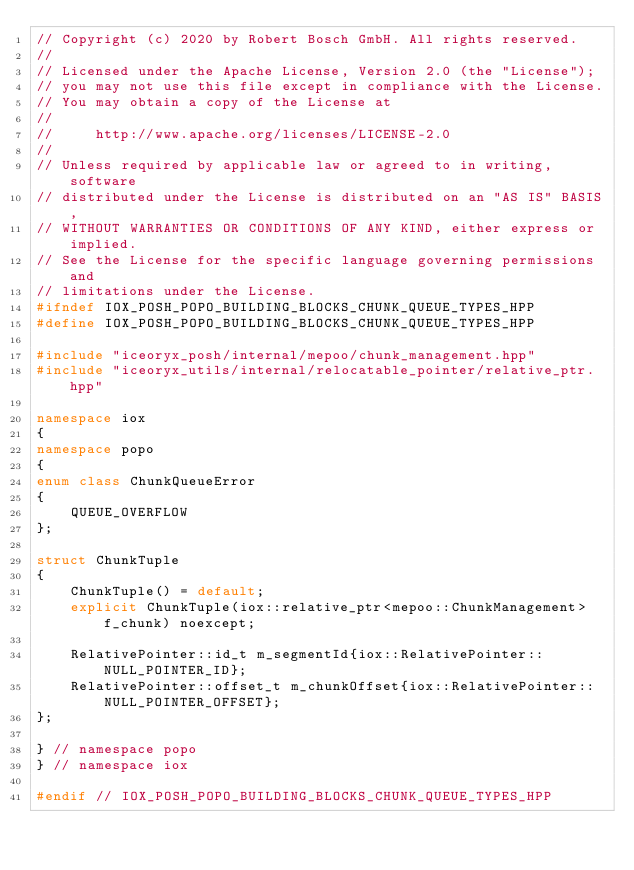Convert code to text. <code><loc_0><loc_0><loc_500><loc_500><_C++_>// Copyright (c) 2020 by Robert Bosch GmbH. All rights reserved.
//
// Licensed under the Apache License, Version 2.0 (the "License");
// you may not use this file except in compliance with the License.
// You may obtain a copy of the License at
//
//     http://www.apache.org/licenses/LICENSE-2.0
//
// Unless required by applicable law or agreed to in writing, software
// distributed under the License is distributed on an "AS IS" BASIS,
// WITHOUT WARRANTIES OR CONDITIONS OF ANY KIND, either express or implied.
// See the License for the specific language governing permissions and
// limitations under the License.
#ifndef IOX_POSH_POPO_BUILDING_BLOCKS_CHUNK_QUEUE_TYPES_HPP
#define IOX_POSH_POPO_BUILDING_BLOCKS_CHUNK_QUEUE_TYPES_HPP

#include "iceoryx_posh/internal/mepoo/chunk_management.hpp"
#include "iceoryx_utils/internal/relocatable_pointer/relative_ptr.hpp"

namespace iox
{
namespace popo
{
enum class ChunkQueueError
{
    QUEUE_OVERFLOW
};

struct ChunkTuple
{
    ChunkTuple() = default;
    explicit ChunkTuple(iox::relative_ptr<mepoo::ChunkManagement> f_chunk) noexcept;

    RelativePointer::id_t m_segmentId{iox::RelativePointer::NULL_POINTER_ID};
    RelativePointer::offset_t m_chunkOffset{iox::RelativePointer::NULL_POINTER_OFFSET};
};

} // namespace popo
} // namespace iox

#endif // IOX_POSH_POPO_BUILDING_BLOCKS_CHUNK_QUEUE_TYPES_HPP
</code> 